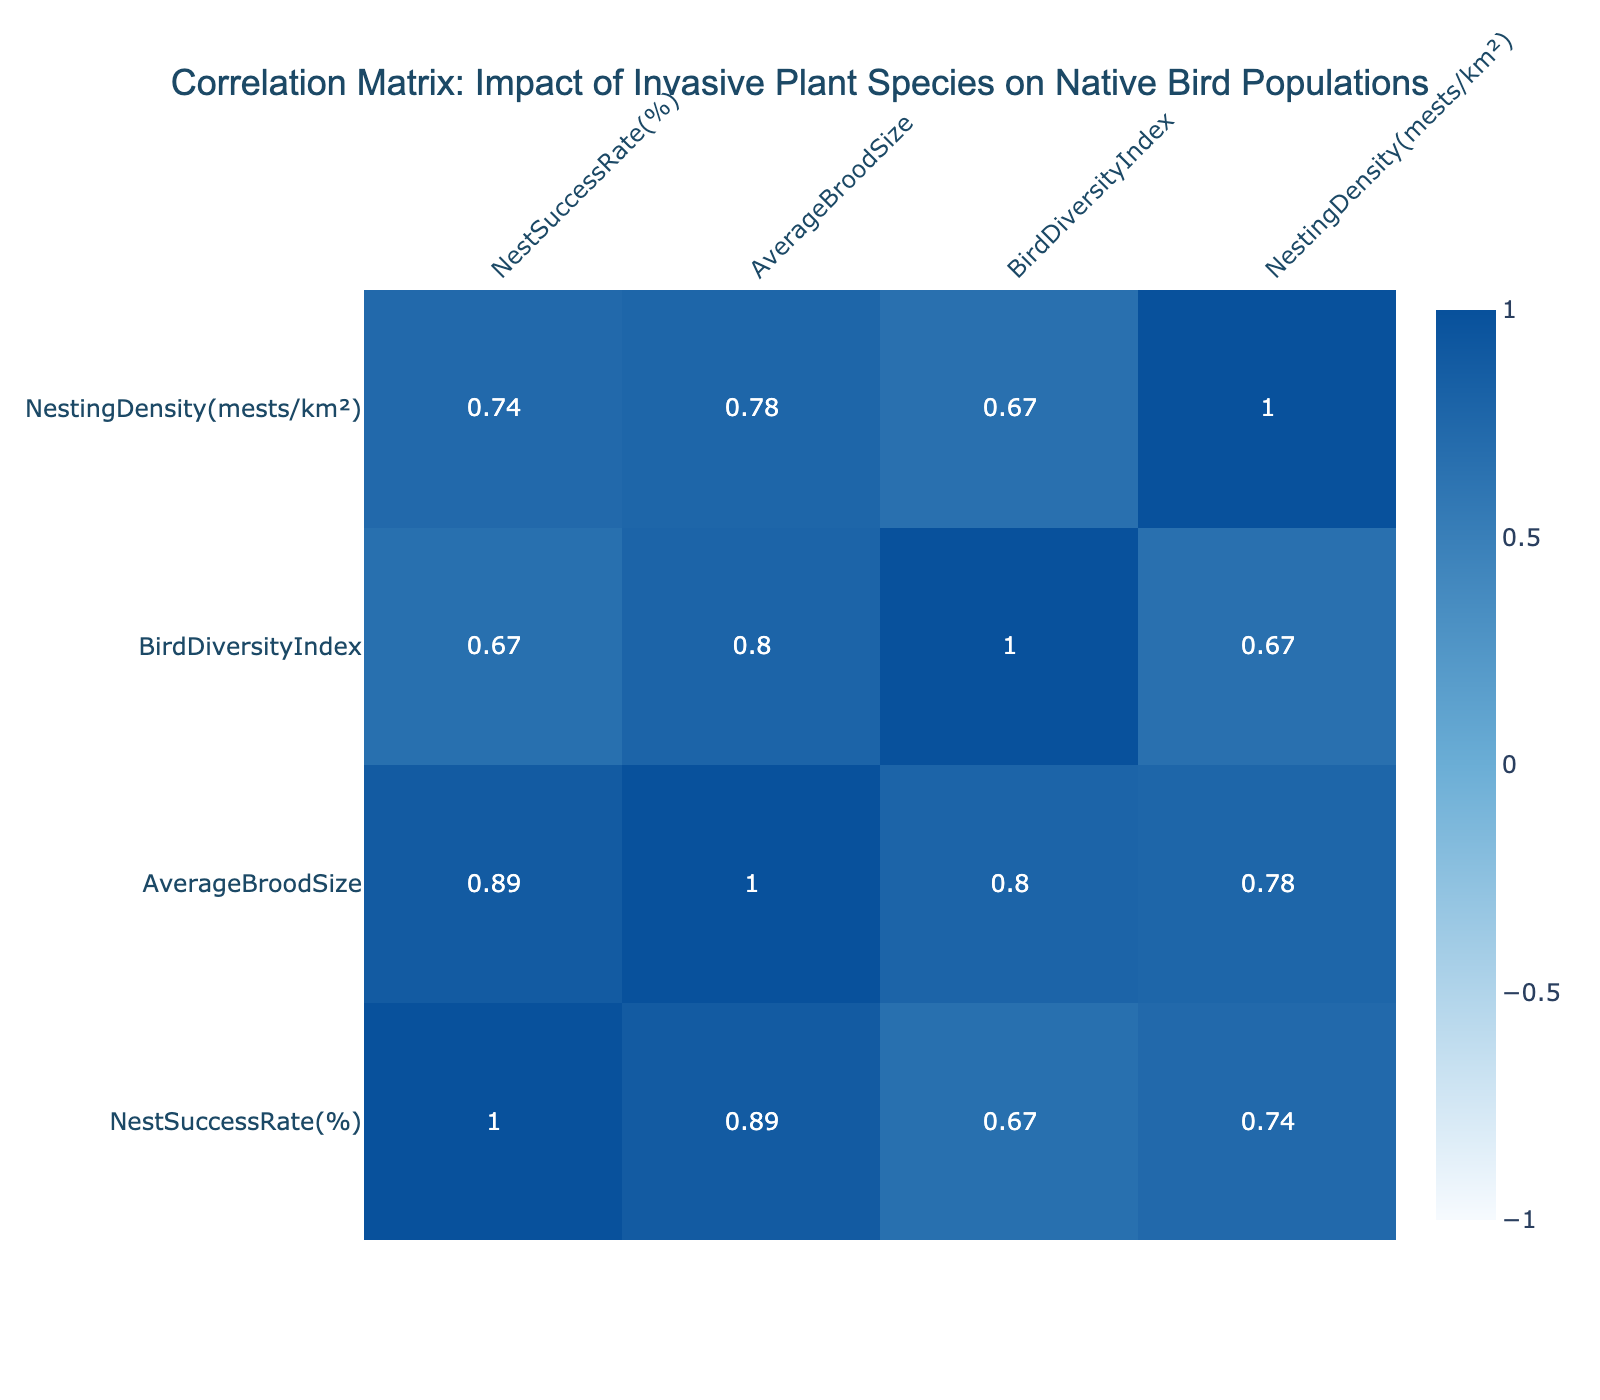What is the Nest Success Rate of Japanese Knotweed? The Nest Success Rate is provided directly in the table for each invasive plant species. For Japanese Knotweed, the value is found in the corresponding row under the "Nest Success Rate(%)" column.
Answer: 34 Which invasive plant species has the highest Average Brood Size? To determine which invasive plant species has the highest Average Brood Size, we can look at the "Average Brood Size" column and find the maximum value. Amur Honeysuckle has the highest value of 2.7.
Answer: Amur Honeysuckle Is there a positive correlation between Bird Diversity Index and Nest Success Rate? To assess the correlation, we can look at the correlation coefficient between the "Bird Diversity Index" and "Nest Success Rate" in the correlation matrix. If the value is greater than 0, it indicates a positive correlation. In the table, the correlation coefficient is positive.
Answer: Yes What is the difference in Nest Success Rate between the highest and lowest invasive plant species? To find the difference, identify the highest Nest Success Rate (Amur Honeysuckle at 50) and the lowest (English Ivy at 27). Subtract the lowest from the highest: 50 - 27 = 23.
Answer: 23 What is the average Bird Diversity Index among the invasive plant species? To calculate the average, sum the Bird Diversity Index values for all species (3.8 + 2.5 + 3.0 + 4.0 + 3.2 + 2.8 + 3.5 + 2.7) which equals 22.5, and then divide by the number of species (8). The average is 22.5 / 8, which equals 2.8125.
Answer: 2.81 Which invasive species has the lowest Nesting Density? By examining the "Nesting Density(mests/km²)" column, we find the lowest value, which corresponds to English Ivy with a value of 5.2.
Answer: English Ivy Do species with higher Average Brood Size also have higher Nest Success Rates? To answer, compare the Average Brood Sizes and Nest Success Rates in the table. For instance, Amur Honeysuckle has a brood size of 2.7 and a success rate of 50%, while English Ivy has a brood size of 1.8 and a success rate of 27%. Most species show this trend of higher brood sizes leading to higher success rates, but this requires further statistical analysis to confirm.
Answer: Generally Yes Which invasive plant species shows the most success in nesting based on Nest Success Rate and Nesting Density? To determine this, we consider both the Nest Success Rate and Nesting Density. Amur Honeysuckle has the highest Nest Success Rate at 50 and a relatively high Nesting Density of 9.5. Thus, it demonstrates both success in nesting and a good density.
Answer: Amur Honeysuckle 